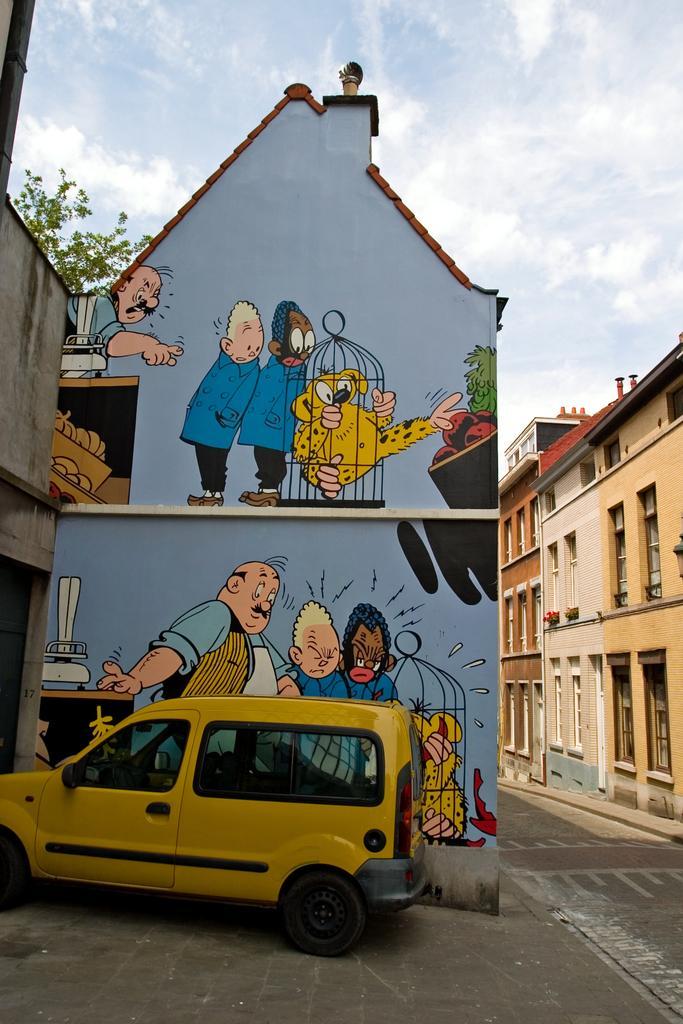Could you give a brief overview of what you see in this image? In this image there is a car on the pavement, beside the car there are some cartoon paintings on the wall, behind the car there is a road, beside the road there are buildings, in front of the car there is a shed, behind the shed there is a tree, at the top of the image there are clouds in the sky. 